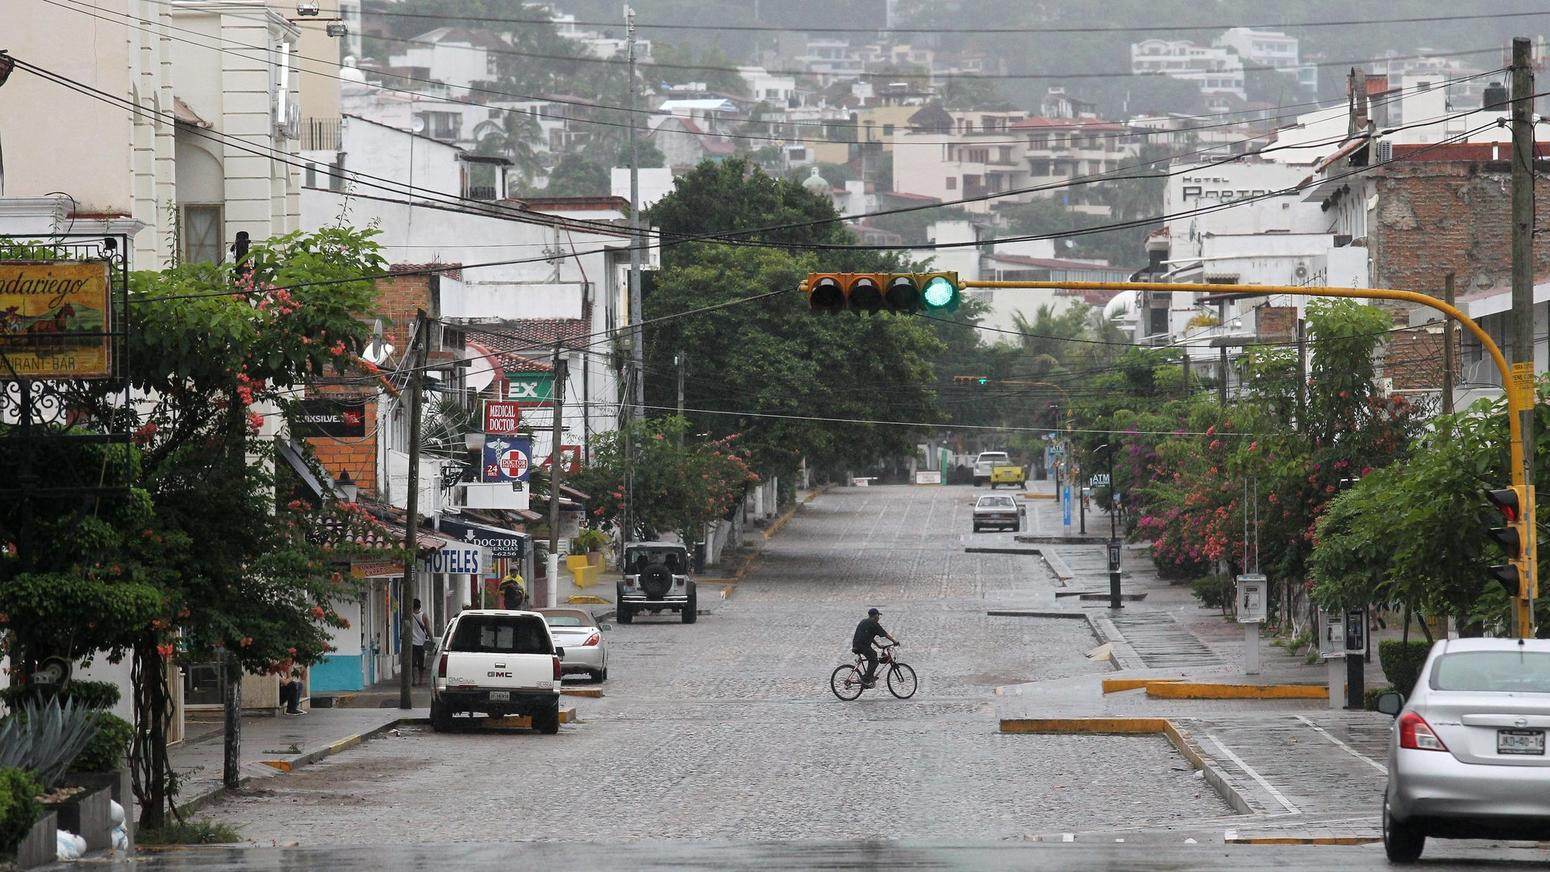Can you describe any cultural or historical significance that may be reflected through the architecture or street design visible in the image? The architecture, with its use of vibrant colors and colonial-style balconies, along with the street's cobblestone surface, suggest a historical area that preserves its cultural heritage. The inclusion of modern amenities like ATMs alongside these traditional features indicates a blend of old and new, reflecting an appreciation for the past while accommodating contemporary needs. This juxtaposition could attract tourists seeking authentic experiences, as well as fostering a sense of continuity and pride among locals. 